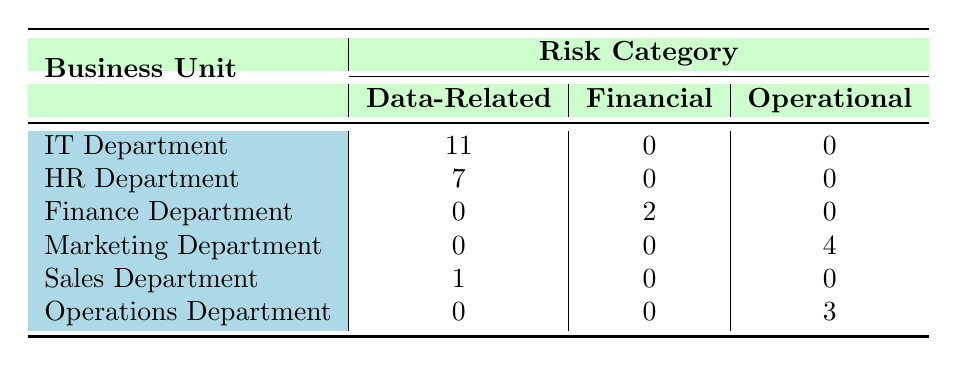What is the total number of data-related occurrences in the IT Department? The IT Department has two rows related to data-related risks: Data Breach (5 occurrences) and Phishing Attacks (6 occurrences). Summing these, 5 + 6 = 11 occurrences.
Answer: 11 Which department has the highest occurrences of operational risks? The operational risks are recorded under the Marketing Department (4 occurrences) and the Operations Department (3 occurrences). The highest is the Marketing Department with 4 occurrences.
Answer: Marketing Department Did the Finance Department have any occurrences of data-related risks? Upon reviewing the Finance Department, there are no entries under the Data-Related column, as it only has entries in Financial risks (Fraud with 2 occurrences). Thus, the answer is no.
Answer: No What is the sum of occurrences for the HR Department across all risk categories? The HR Department has two risks: Compliance (3 occurrences) and Data Privacy (4 occurrences). Therefore, summing these gives 3 + 4 = 7 occurrences in total.
Answer: 7 Which department indicates a risk of data loss, and what is the severity level of that risk? The Sales Department is listed with 1 occurrence of Data Loss, and the severity is categorized as Low.
Answer: Sales Department, Low severity Is there any department with no recorded occurrences of financial risks? The table shows that the IT Department, HR Department, and Operations Department all have 0 occurrences in the Financial column, confirming that at least three departments have no financial risks.
Answer: Yes What can be deduced about the number of risks in the IT Department compared to the HR Department? The IT Department has a total of 11 occurrences (5 for Data Breach and 6 for Phishing Attacks) while the HR Department has 7 occurrences (3 for Compliance and 4 for Data Privacy). The IT Department has more total risks than the HR Department by 4 occurrences.
Answer: IT Department has more risks by 4 occurrences Calculate the average occurrences of operational risks across all departments. Only the Marketing Department (4 occurrences) and Operations Department (3 occurrences) have operational risks. Thus, we find the average: (4 + 3) / 2 = 3.5 occurrences.
Answer: 3.5 What level of severity is reported for the occurrences in the Marketing Department? The Marketing Department has a risk categorized as Reputation Damage with 4 occurrences, but the severity is noted as Medium. Thus, it has a Medium severity level.
Answer: Medium severity 